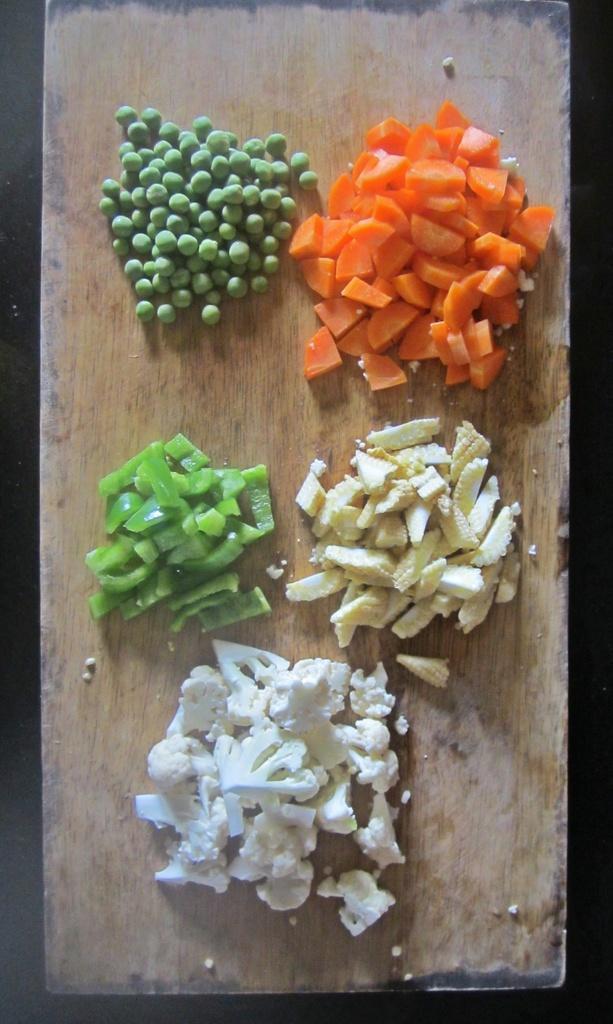How would you summarize this image in a sentence or two? In this picture we can see there are green peas and there are chopping vegetables on the chopping board. 